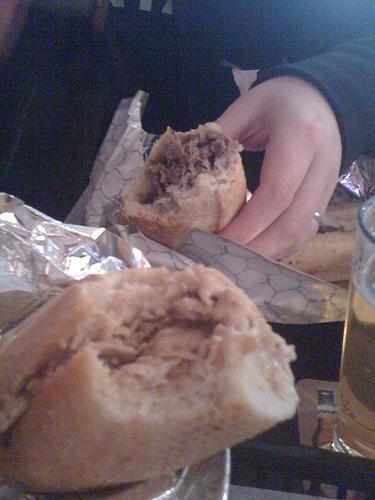How many sandwiches are shown?
Give a very brief answer. 2. 